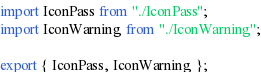<code> <loc_0><loc_0><loc_500><loc_500><_TypeScript_>import IconPass from "./IconPass";
import IconWarning from "./IconWarning";

export { IconPass, IconWarning };
</code> 